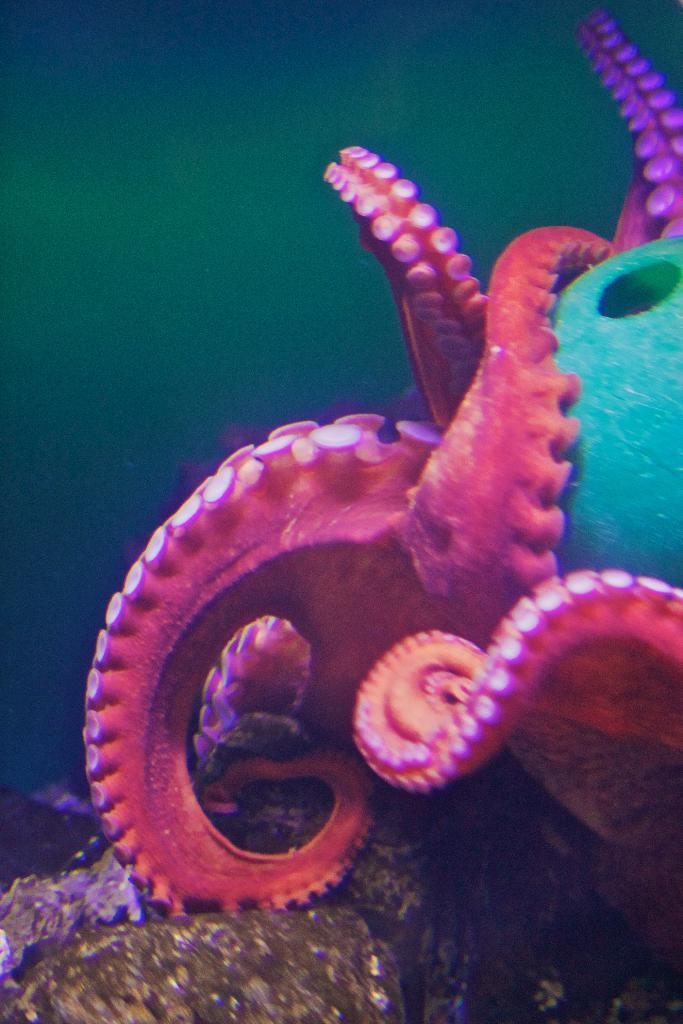Where was the picture taken? The picture was taken underwater. What is the main subject in the center of the image? There is an octopus in the center of the image. What can be seen at the bottom of the image? There is a rock at the bottom of the image. What type of jewel can be seen in the image? There is no jewel present in the image; it is taken underwater and features an octopus and a rock. 